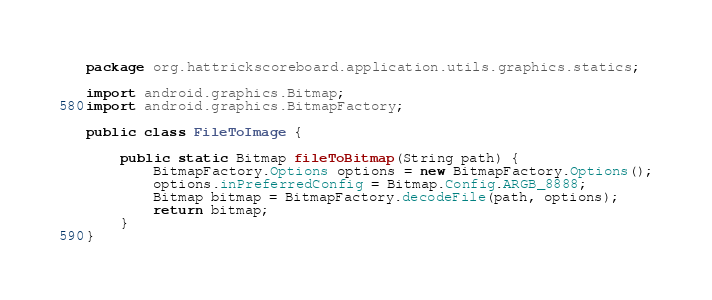<code> <loc_0><loc_0><loc_500><loc_500><_Java_>package org.hattrickscoreboard.application.utils.graphics.statics;

import android.graphics.Bitmap;
import android.graphics.BitmapFactory;

public class FileToImage {

    public static Bitmap fileToBitmap(String path) {
        BitmapFactory.Options options = new BitmapFactory.Options();
        options.inPreferredConfig = Bitmap.Config.ARGB_8888;
        Bitmap bitmap = BitmapFactory.decodeFile(path, options);
        return bitmap;
    }
}
</code> 